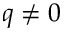Convert formula to latex. <formula><loc_0><loc_0><loc_500><loc_500>q \neq 0</formula> 